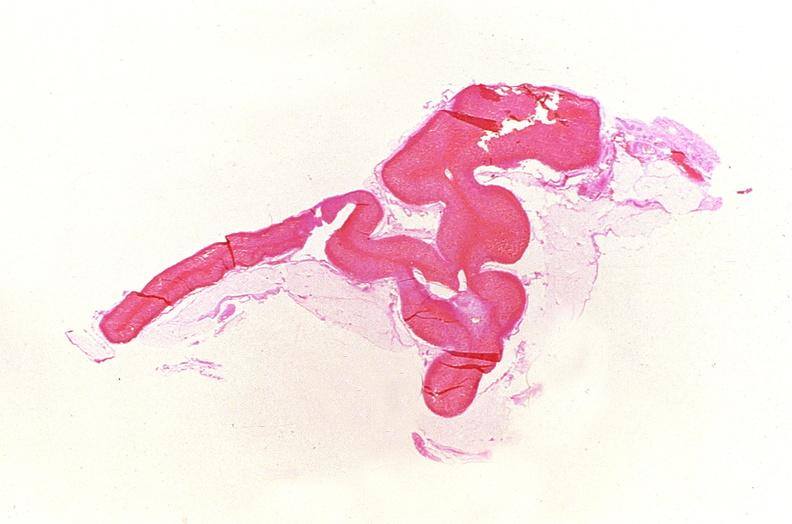s marked present?
Answer the question using a single word or phrase. No 